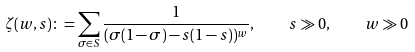<formula> <loc_0><loc_0><loc_500><loc_500>\zeta ( w , s ) \colon = \sum _ { \sigma \in S } \frac { 1 } { ( \sigma ( 1 - \sigma ) - s ( 1 - s ) ) ^ { w } } , \quad s \gg 0 , \quad w \gg 0</formula> 